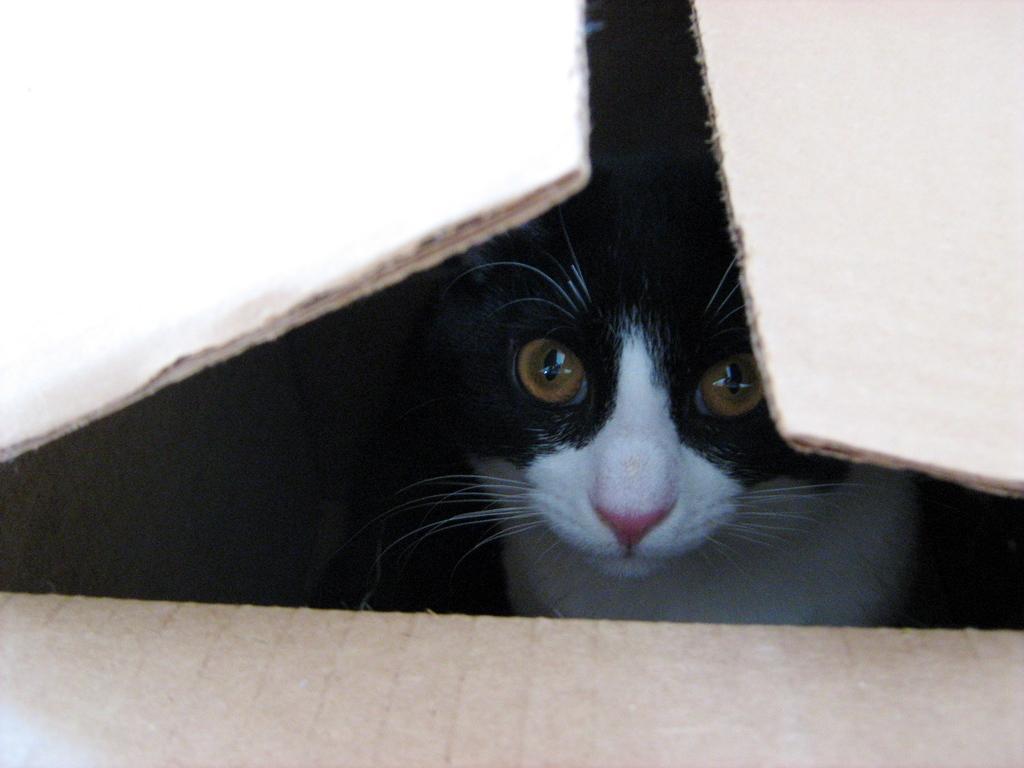Could you give a brief overview of what you see in this image? In the image we can see a cat in the box. 